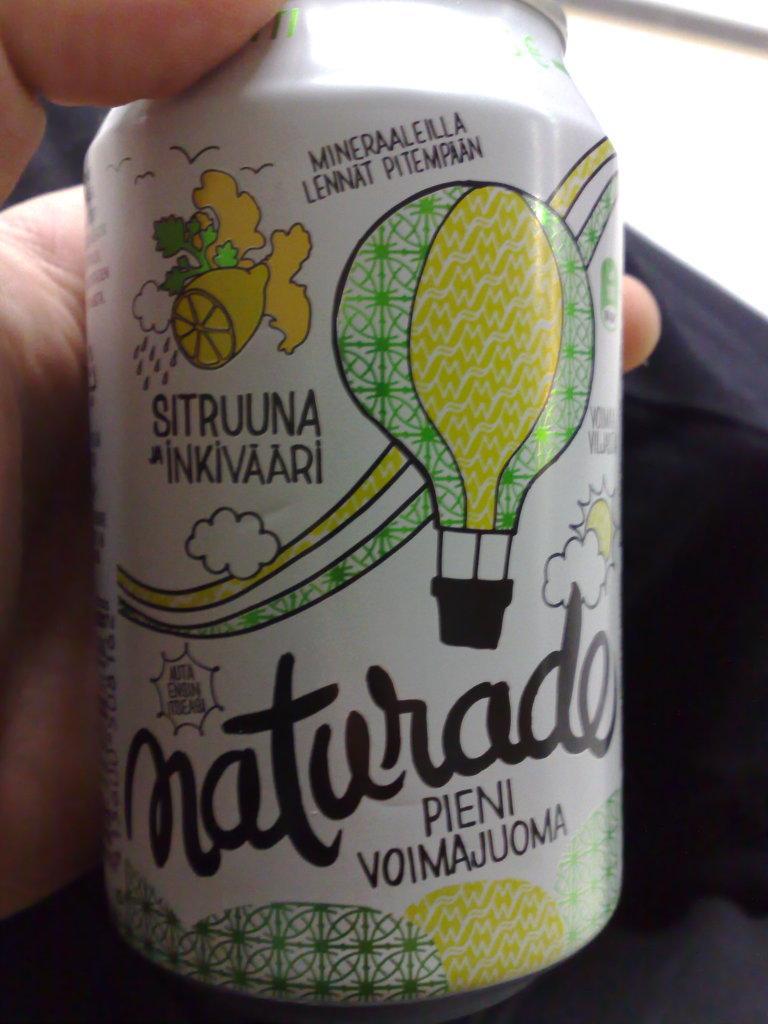Can you describe this image briefly? The picture consists of a person holding a tin, on the tin there are some pictures and text. 